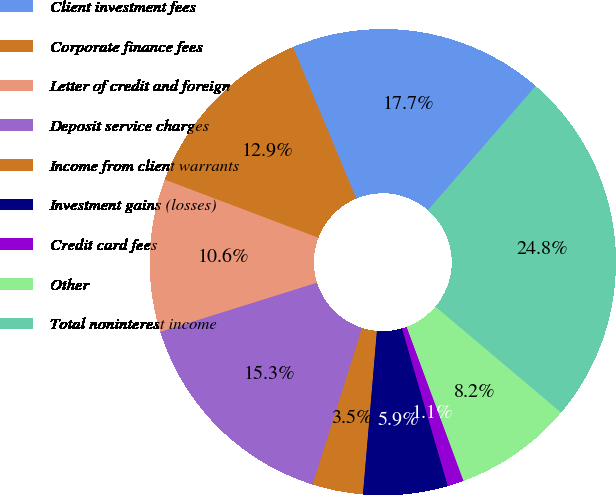Convert chart. <chart><loc_0><loc_0><loc_500><loc_500><pie_chart><fcel>Client investment fees<fcel>Corporate finance fees<fcel>Letter of credit and foreign<fcel>Deposit service charges<fcel>Income from client warrants<fcel>Investment gains (losses)<fcel>Credit card fees<fcel>Other<fcel>Total noninterest income<nl><fcel>17.68%<fcel>12.95%<fcel>10.59%<fcel>15.31%<fcel>3.5%<fcel>5.86%<fcel>1.13%<fcel>8.22%<fcel>24.77%<nl></chart> 